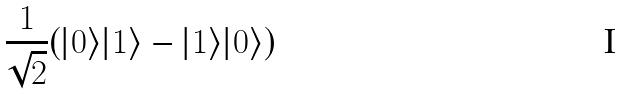<formula> <loc_0><loc_0><loc_500><loc_500>\frac { 1 } { \sqrt { 2 } } ( | 0 \rangle | 1 \rangle - | 1 \rangle | 0 \rangle )</formula> 